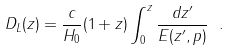Convert formula to latex. <formula><loc_0><loc_0><loc_500><loc_500>D _ { L } ( z ) = \frac { c } { H _ { 0 } } ( 1 + z ) \int _ { 0 } ^ { z } { \frac { d z ^ { \prime } } { E ( z ^ { \prime } , { p } ) } } \ .</formula> 